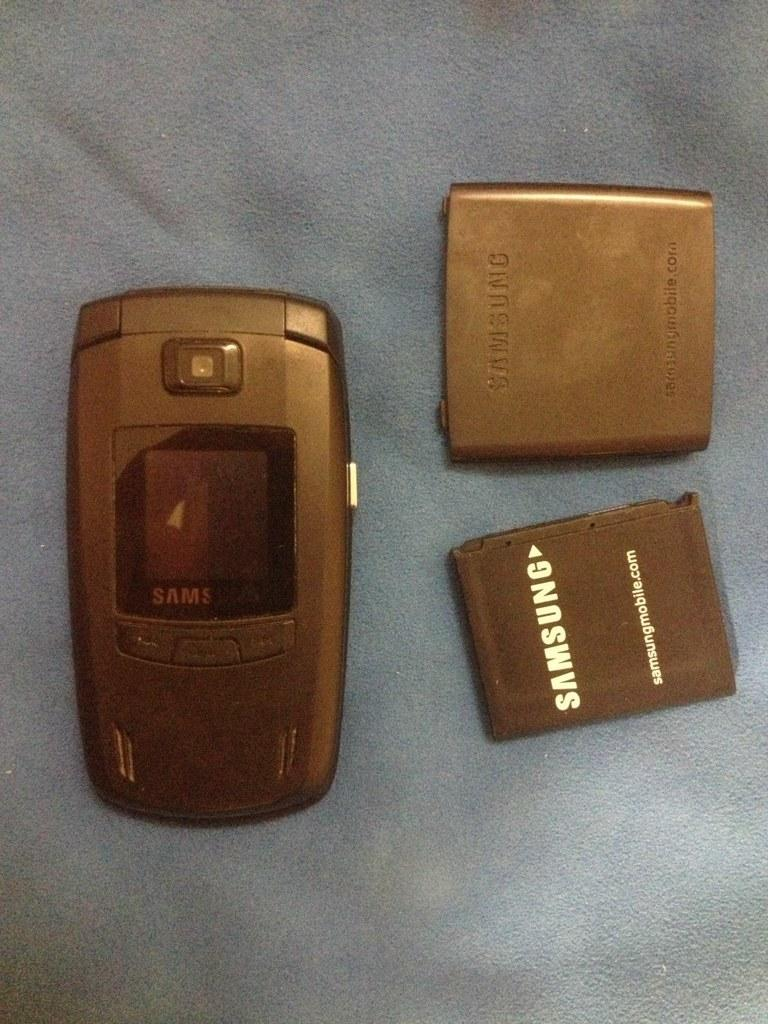Provide a one-sentence caption for the provided image. A battery has been removed from a Samsung phone and sits next to it on a blue surface. 